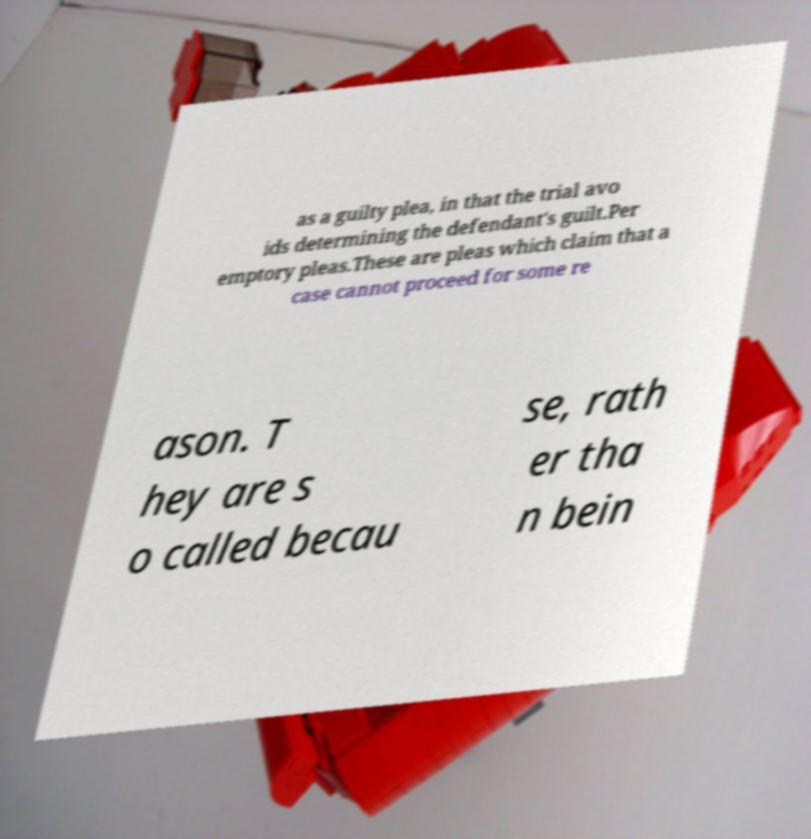Can you accurately transcribe the text from the provided image for me? as a guilty plea, in that the trial avo ids determining the defendant's guilt.Per emptory pleas.These are pleas which claim that a case cannot proceed for some re ason. T hey are s o called becau se, rath er tha n bein 